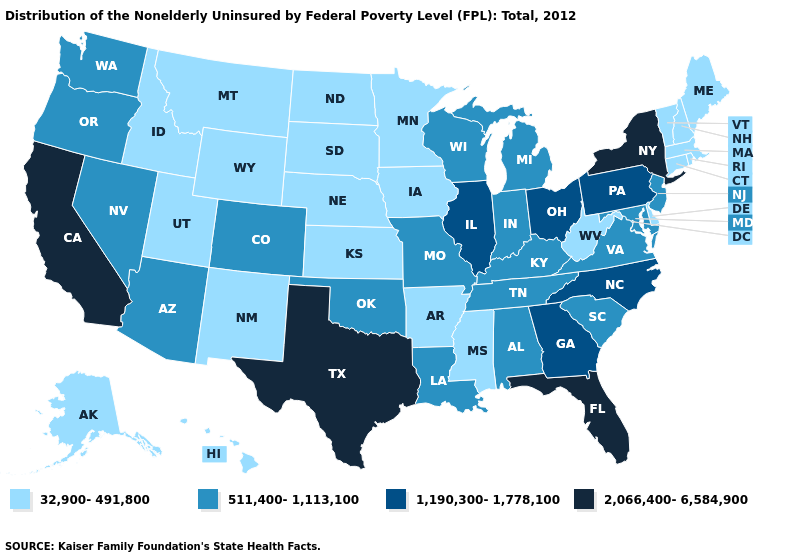What is the value of Vermont?
Write a very short answer. 32,900-491,800. Name the states that have a value in the range 1,190,300-1,778,100?
Short answer required. Georgia, Illinois, North Carolina, Ohio, Pennsylvania. Does Nevada have the same value as Michigan?
Keep it brief. Yes. Which states have the lowest value in the South?
Be succinct. Arkansas, Delaware, Mississippi, West Virginia. Does the first symbol in the legend represent the smallest category?
Short answer required. Yes. What is the highest value in the West ?
Write a very short answer. 2,066,400-6,584,900. Which states have the lowest value in the USA?
Short answer required. Alaska, Arkansas, Connecticut, Delaware, Hawaii, Idaho, Iowa, Kansas, Maine, Massachusetts, Minnesota, Mississippi, Montana, Nebraska, New Hampshire, New Mexico, North Dakota, Rhode Island, South Dakota, Utah, Vermont, West Virginia, Wyoming. Does Missouri have the highest value in the MidWest?
Short answer required. No. Does New York have the lowest value in the USA?
Give a very brief answer. No. Among the states that border Nebraska , which have the lowest value?
Answer briefly. Iowa, Kansas, South Dakota, Wyoming. Name the states that have a value in the range 511,400-1,113,100?
Answer briefly. Alabama, Arizona, Colorado, Indiana, Kentucky, Louisiana, Maryland, Michigan, Missouri, Nevada, New Jersey, Oklahoma, Oregon, South Carolina, Tennessee, Virginia, Washington, Wisconsin. What is the value of Oregon?
Write a very short answer. 511,400-1,113,100. Does Arizona have the lowest value in the West?
Concise answer only. No. What is the highest value in the USA?
Short answer required. 2,066,400-6,584,900. 